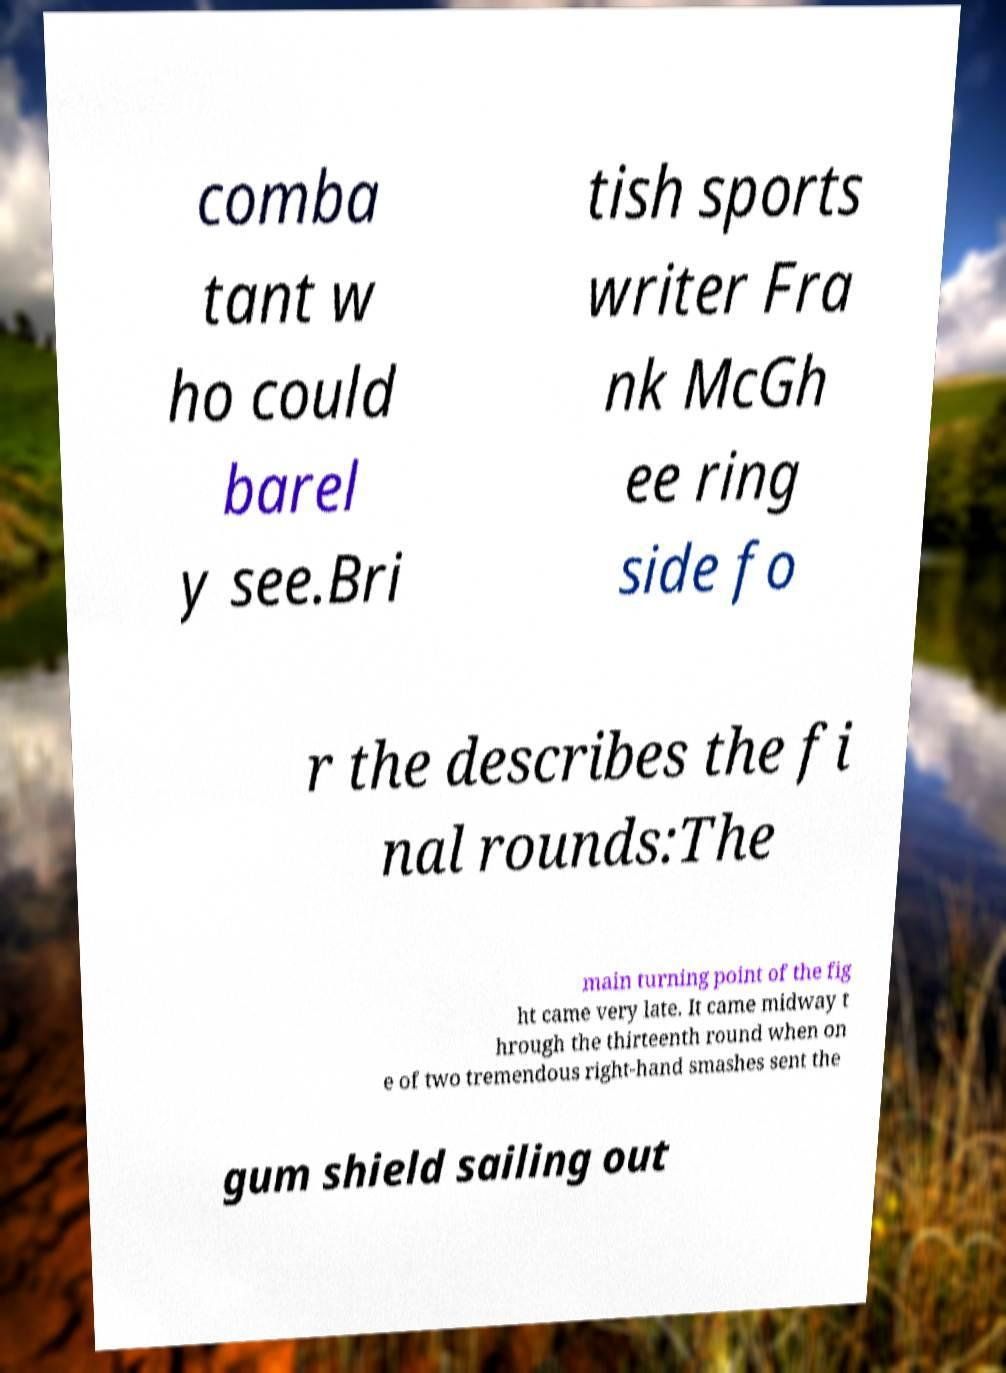Could you assist in decoding the text presented in this image and type it out clearly? comba tant w ho could barel y see.Bri tish sports writer Fra nk McGh ee ring side fo r the describes the fi nal rounds:The main turning point of the fig ht came very late. It came midway t hrough the thirteenth round when on e of two tremendous right-hand smashes sent the gum shield sailing out 